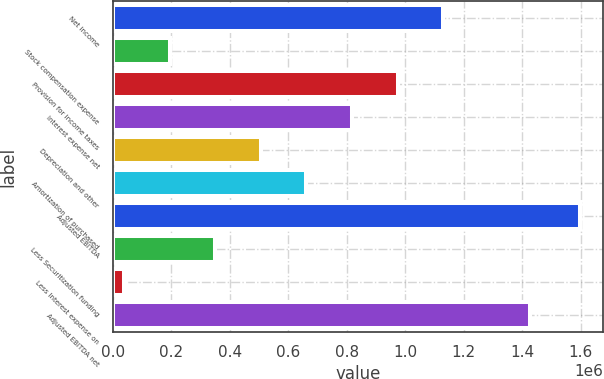Convert chart to OTSL. <chart><loc_0><loc_0><loc_500><loc_500><bar_chart><fcel>Net income<fcel>Stock compensation expense<fcel>Provision for income taxes<fcel>Interest expense net<fcel>Depreciation and other<fcel>Amortization of purchased<fcel>Adjusted EBITDA<fcel>Less Securitization funding<fcel>Less Interest expense on<fcel>Adjusted EBITDA net<nl><fcel>1.12934e+06<fcel>193514<fcel>973371<fcel>817400<fcel>505457<fcel>661428<fcel>1.59726e+06<fcel>349486<fcel>37543<fcel>1.42556e+06<nl></chart> 